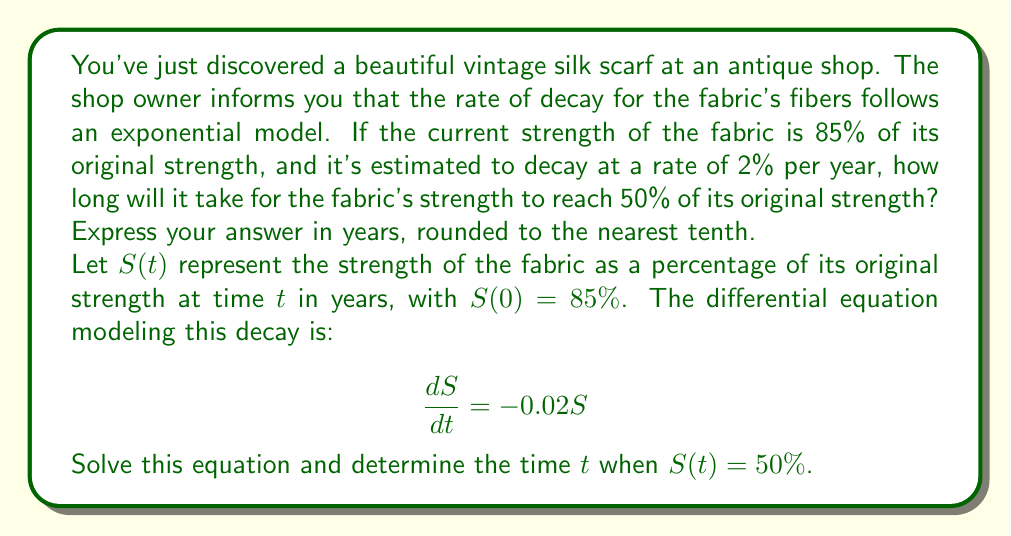Provide a solution to this math problem. To solve this problem, we'll follow these steps:

1) The given differential equation is:

   $$\frac{dS}{dt} = -0.02S$$

2) This is a separable equation. We can rewrite it as:

   $$\frac{dS}{S} = -0.02dt$$

3) Integrating both sides:

   $$\int \frac{dS}{S} = \int -0.02dt$$

   $$\ln|S| = -0.02t + C$$

4) We can rewrite this as:

   $$S = Ae^{-0.02t}$$

   where $A$ is a constant we need to determine.

5) We know that at $t=0$, $S(0) = 85\%$. Let's use this to find $A$:

   $$85 = Ae^{-0.02(0)}$$
   $$85 = A$$

6) So our specific solution is:

   $$S(t) = 85e^{-0.02t}$$

7) Now, we want to find $t$ when $S(t) = 50\%$:

   $$50 = 85e^{-0.02t}$$

8) Dividing both sides by 85:

   $$\frac{50}{85} = e^{-0.02t}$$

9) Taking the natural log of both sides:

   $$\ln(\frac{50}{85}) = -0.02t$$

10) Solving for $t$:

    $$t = \frac{\ln(\frac{50}{85})}{-0.02} \approx 26.64$$

11) Rounding to the nearest tenth:

    $$t \approx 26.6\text{ years}$$
Answer: It will take approximately 26.6 years for the fabric's strength to reach 50% of its original strength. 